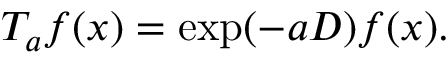<formula> <loc_0><loc_0><loc_500><loc_500>T _ { a } f ( x ) = \exp ( - a D ) f ( x ) .</formula> 